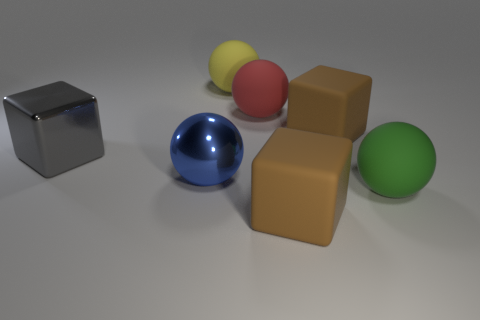Are there any patterns or consistency in the arrangement of the objects? The objects are arranged without a clear pattern, randomly placed on a flat surface. However, there is a slight clustering with two cubes closely positioned and three spheres forming a rough triangular shape. The variety in color and shape provides an aesthetically pleasing, albeit random, display. 